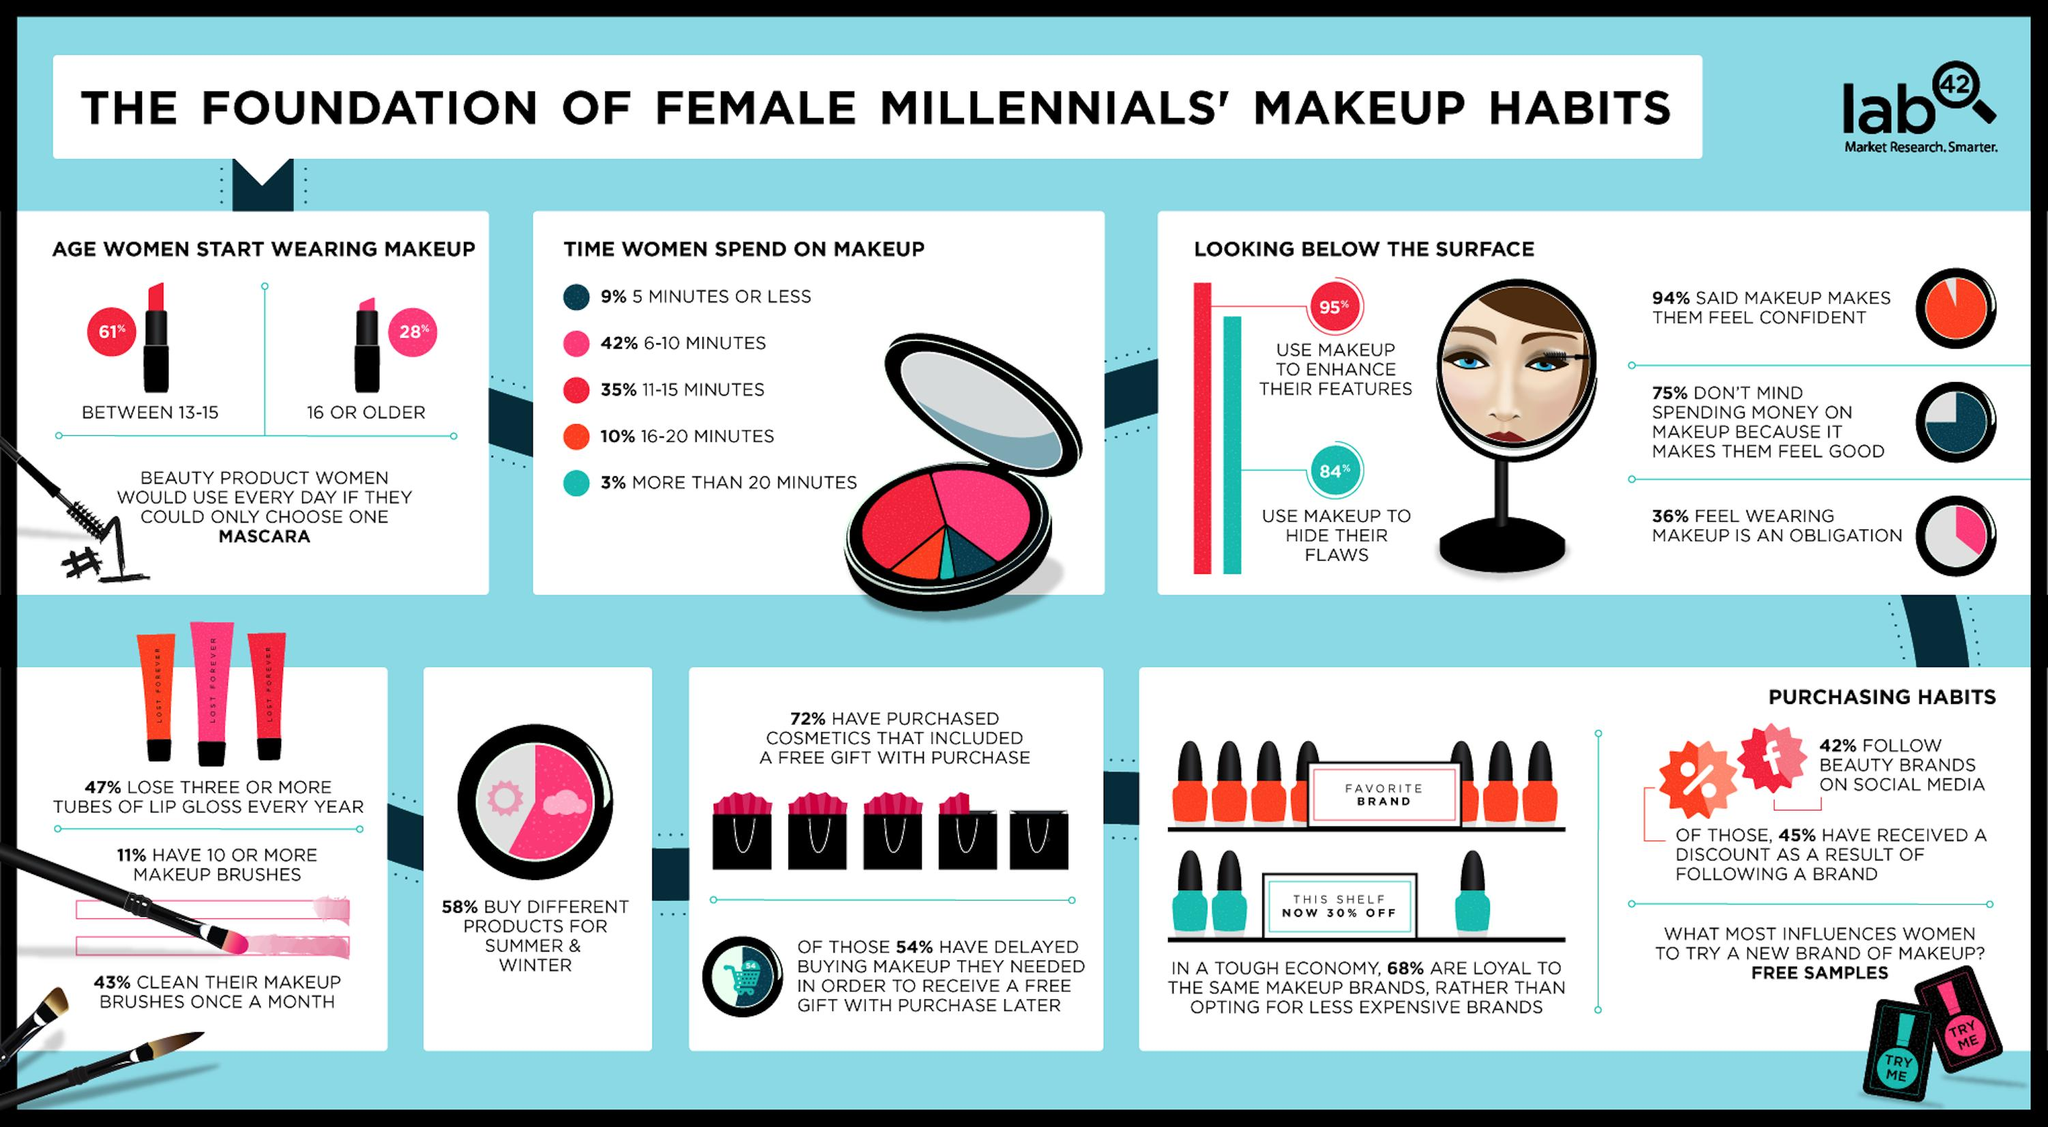Mention a couple of crucial points in this snapshot. According to a survey, 64% of millennial women do not feel that wearing makeup is an obligation. According to a recent study, a significant majority of millennial women, 58%, do not follow beauty brands on social media. According to a survey, 58% of millennial women purchase different makeup products for both summer and winter. According to the given statistic, 84% of millennial women use makeup to conceal their perceived flaws. According to a recent survey, approximately 10% of millennial women spend 16-20 minutes on makeup. 